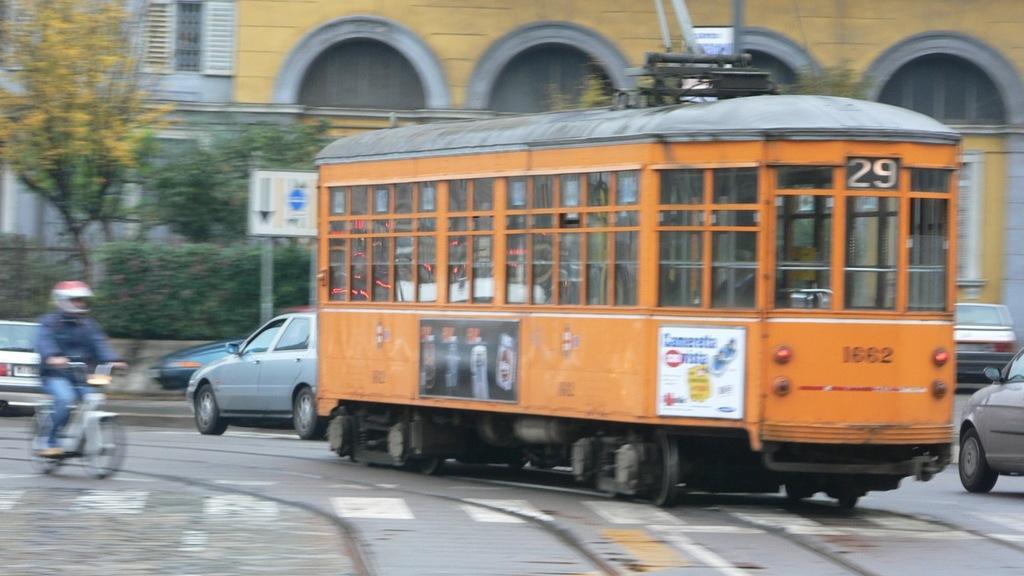Could you give a brief overview of what you see in this image? In the image we can see there are many vehicles on the road. We can even see a person wearing clothes, helmet and the person is riding on the two wheeler. Here we can see trees, plants and the building. 